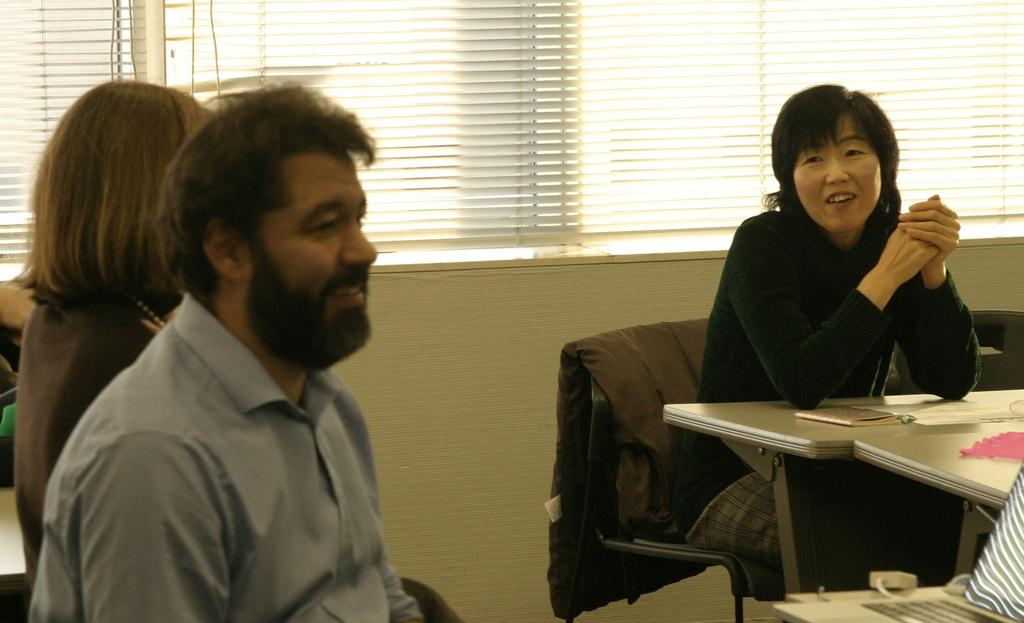What are the people in the image doing? The people in the image are sitting on chairs. Can you describe their expressions? Some of the people have smiles on their faces. Who is the owner of the prose in the image? There is no prose present in the image, so it is not possible to determine an owner. 